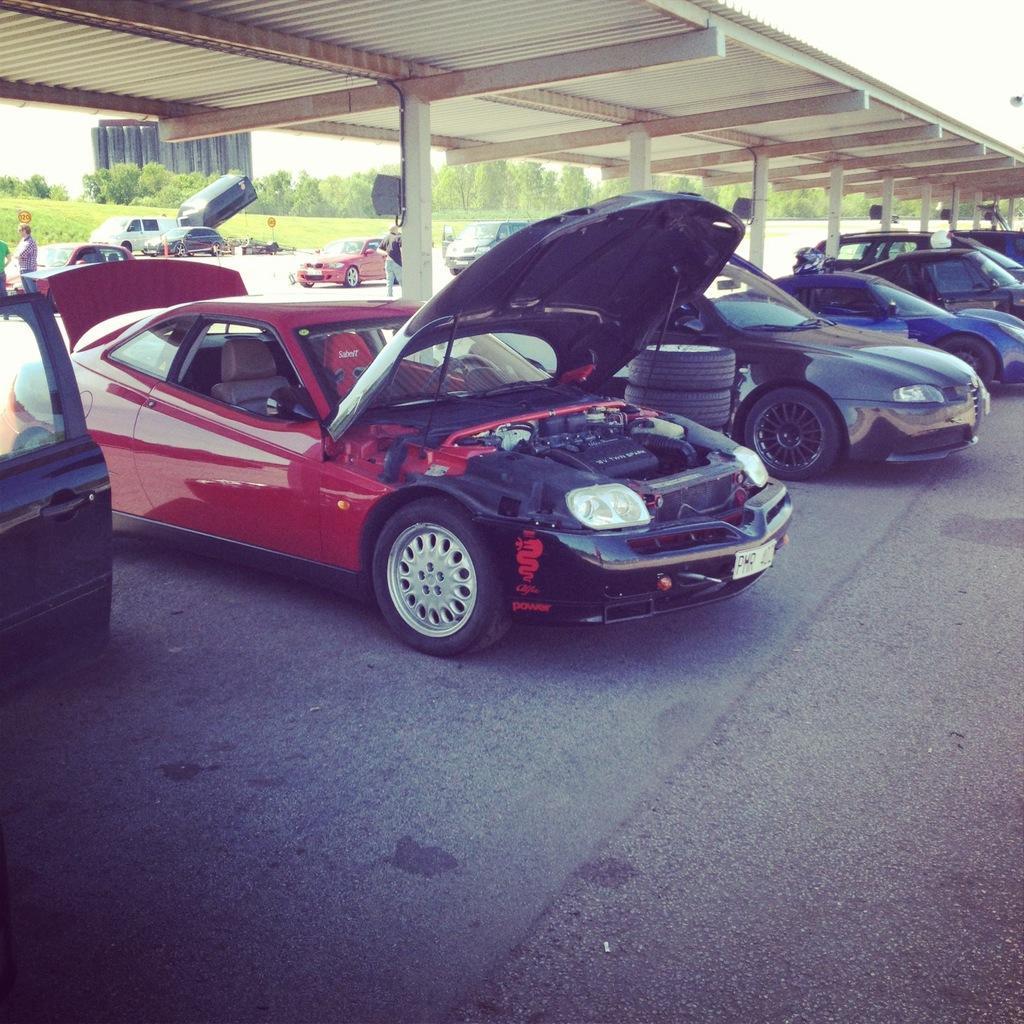Please provide a concise description of this image. This is an outside view. Here I can see many cars on the ground. At the top there is a shed. In the background there are few trees and a building and also I can see the sky. On the left side there are few people standing. 